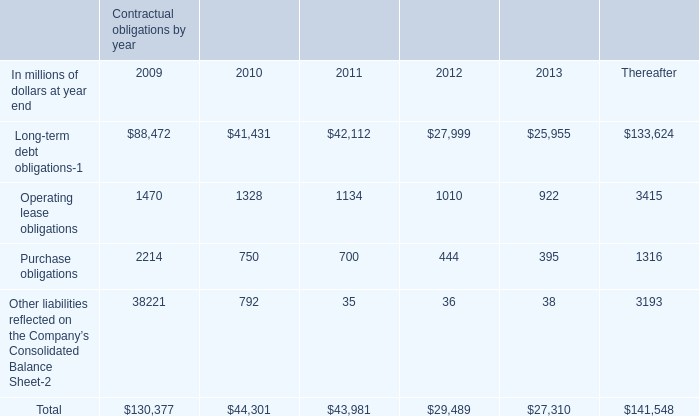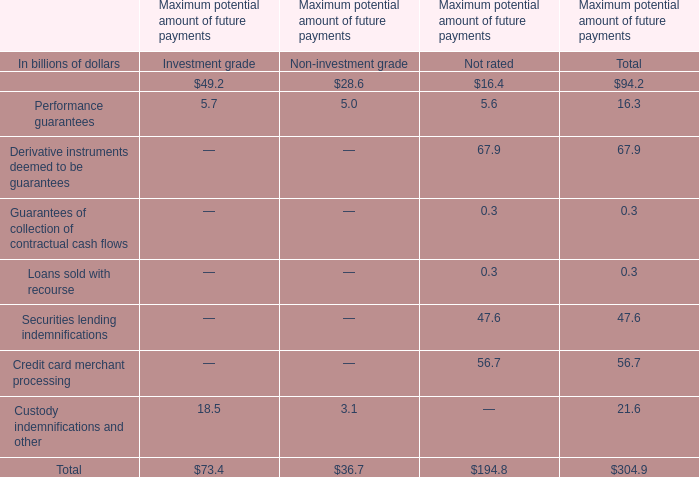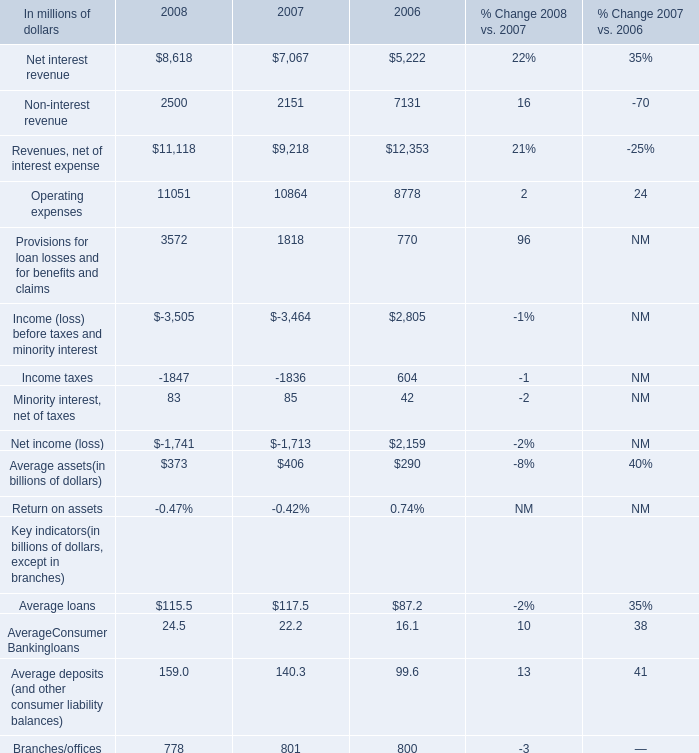In which section is Custody indemnifications and other smaller than Performance guarantees? 
Answer: Non-investment grade. 